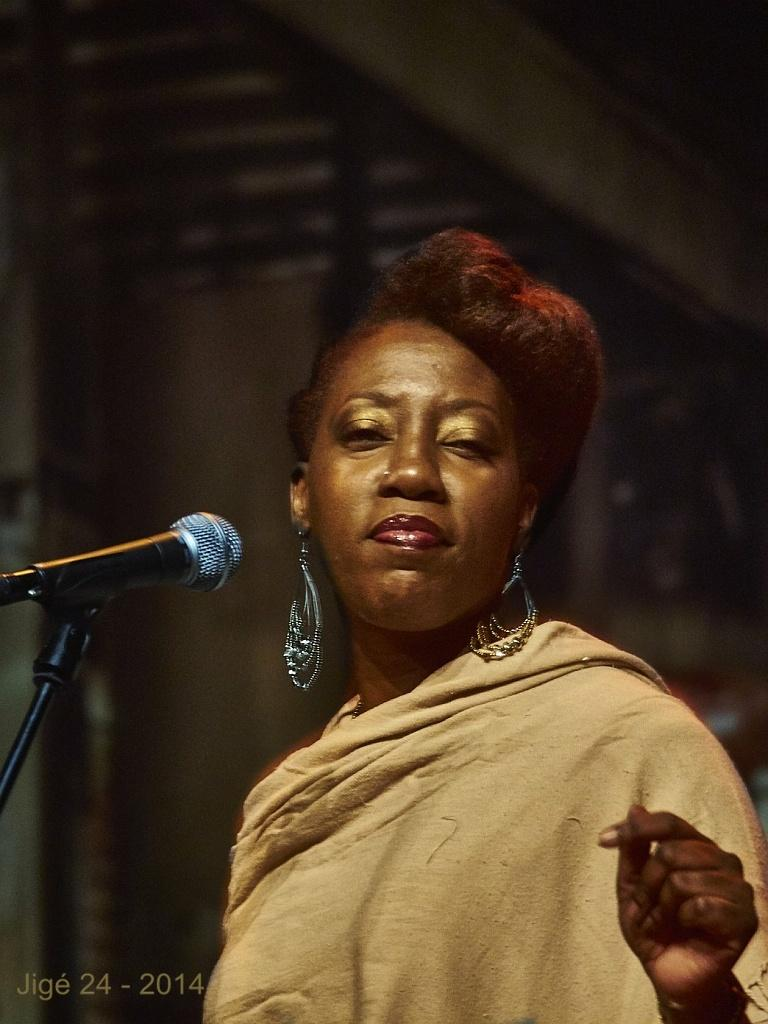Who is the main subject in the image? There is a woman in the image. What object is in front of the woman? There is a microphone (mike) in front of the woman. What type of hand can be seen holding the microphone in the image? There is no hand holding the microphone in the image; it is simply placed in front of the woman. 